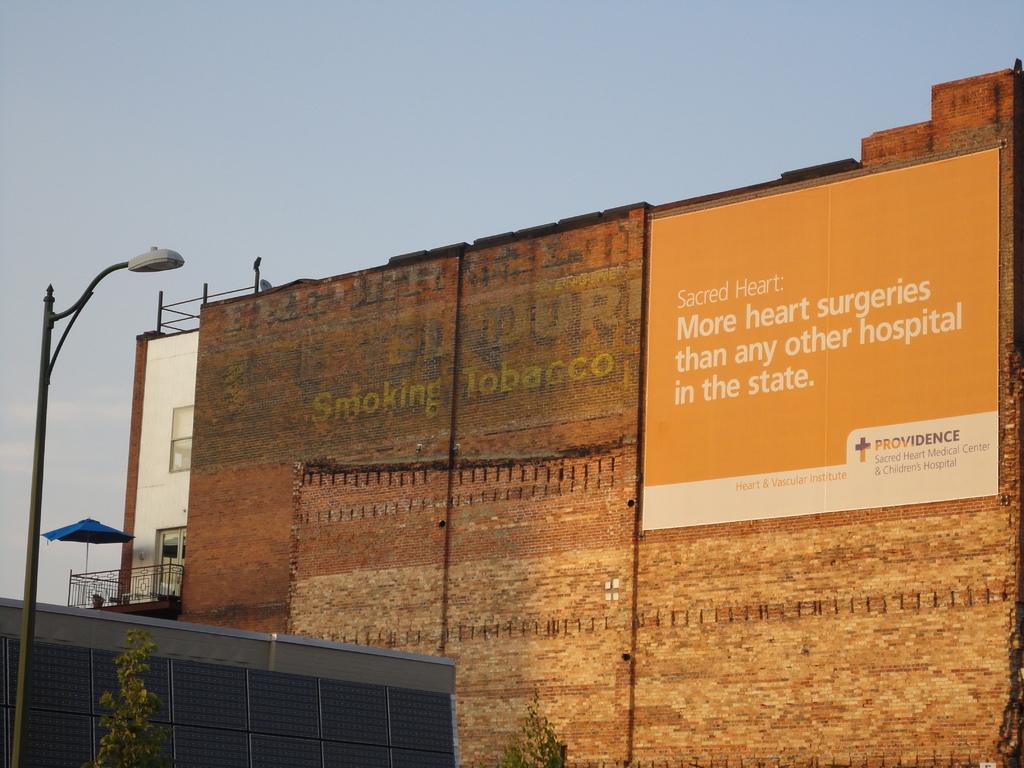In one or two sentences, can you explain what this image depicts? In this picture we can see a pole with light and trees and behind the pole there is a wall with a hoarding. Behind the wall there are buildings and a sky. 